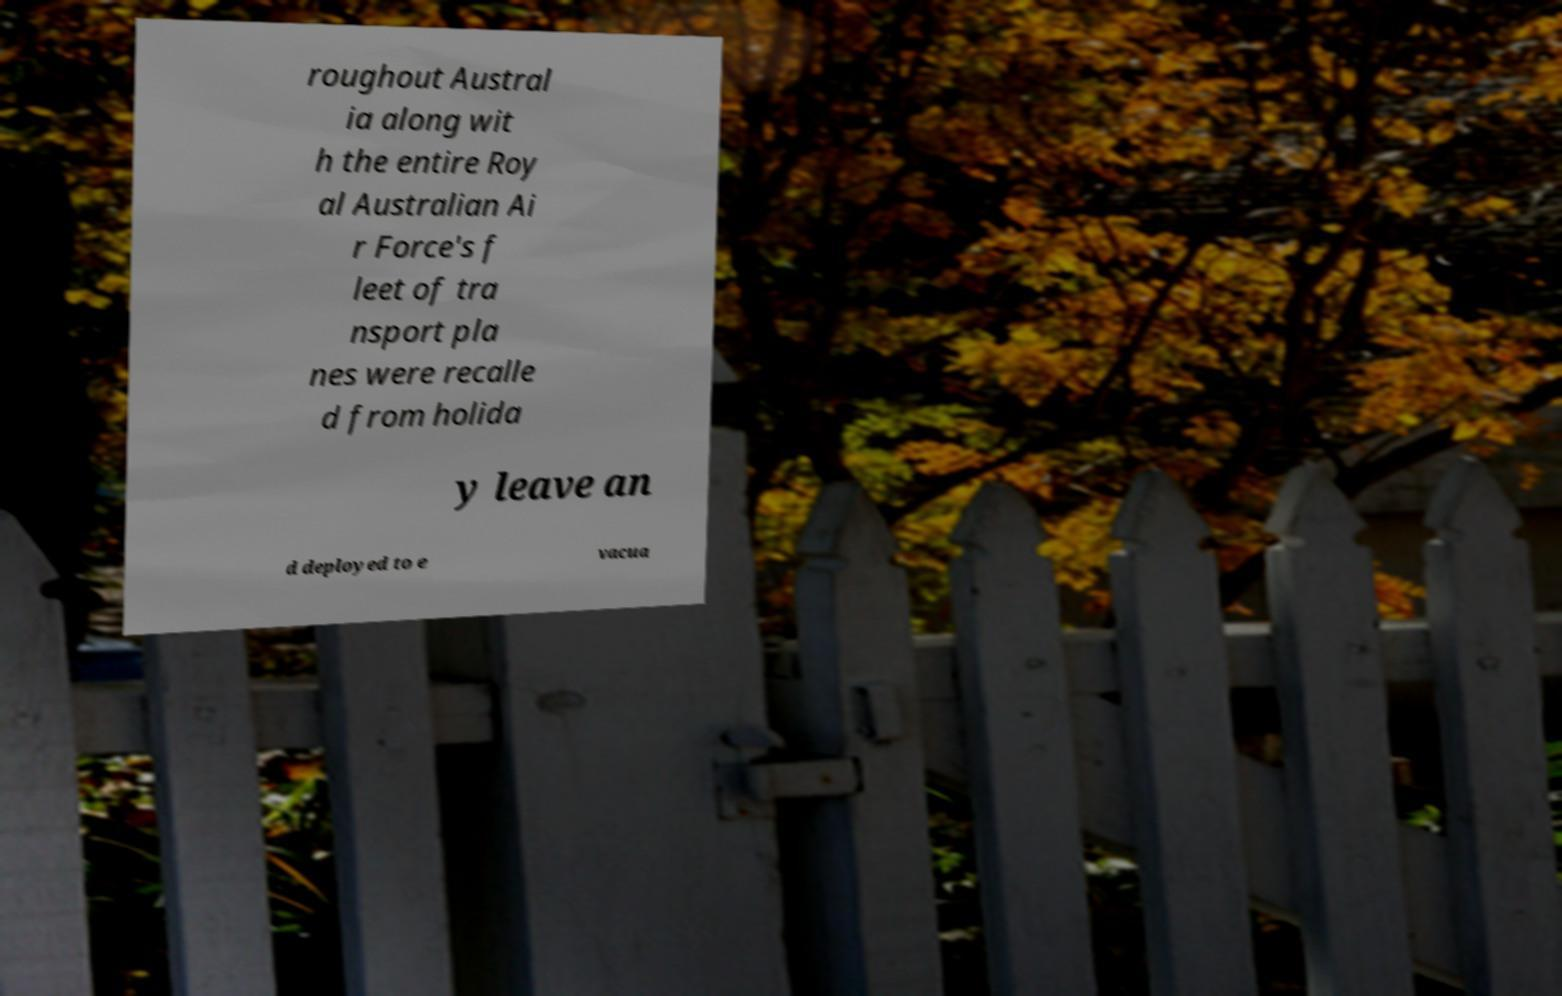For documentation purposes, I need the text within this image transcribed. Could you provide that? roughout Austral ia along wit h the entire Roy al Australian Ai r Force's f leet of tra nsport pla nes were recalle d from holida y leave an d deployed to e vacua 